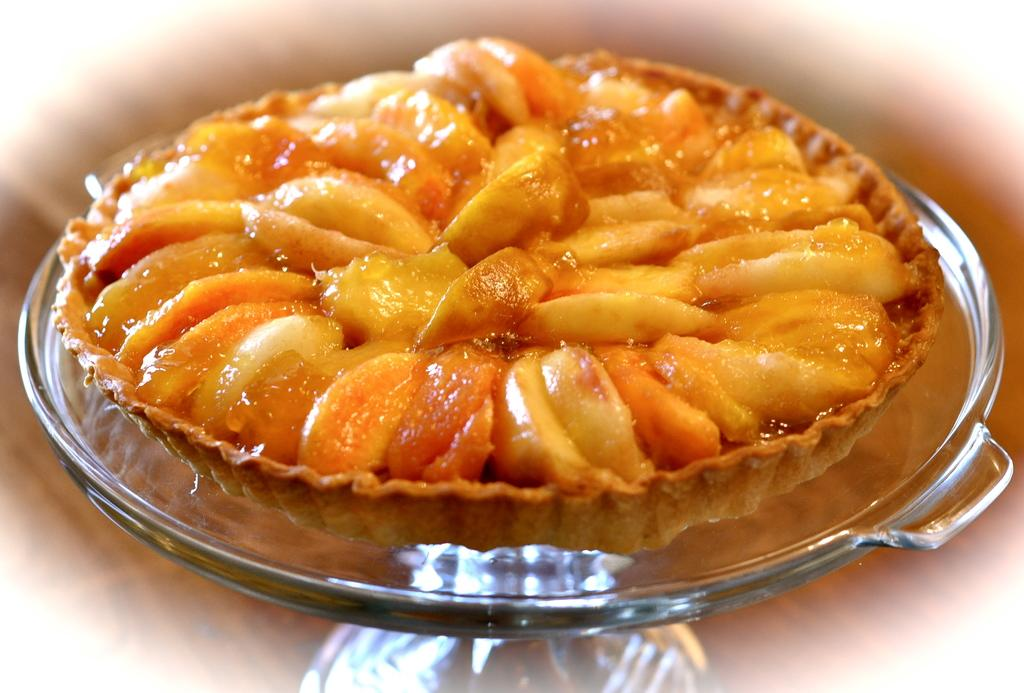What type of container is visible in the image? There is a glass container in the image. What is inside the glass container? The glass container contains food items. How many pigs are flying in the sky above the glass container? There are no pigs visible in the image, and the sky is not shown in the image. 